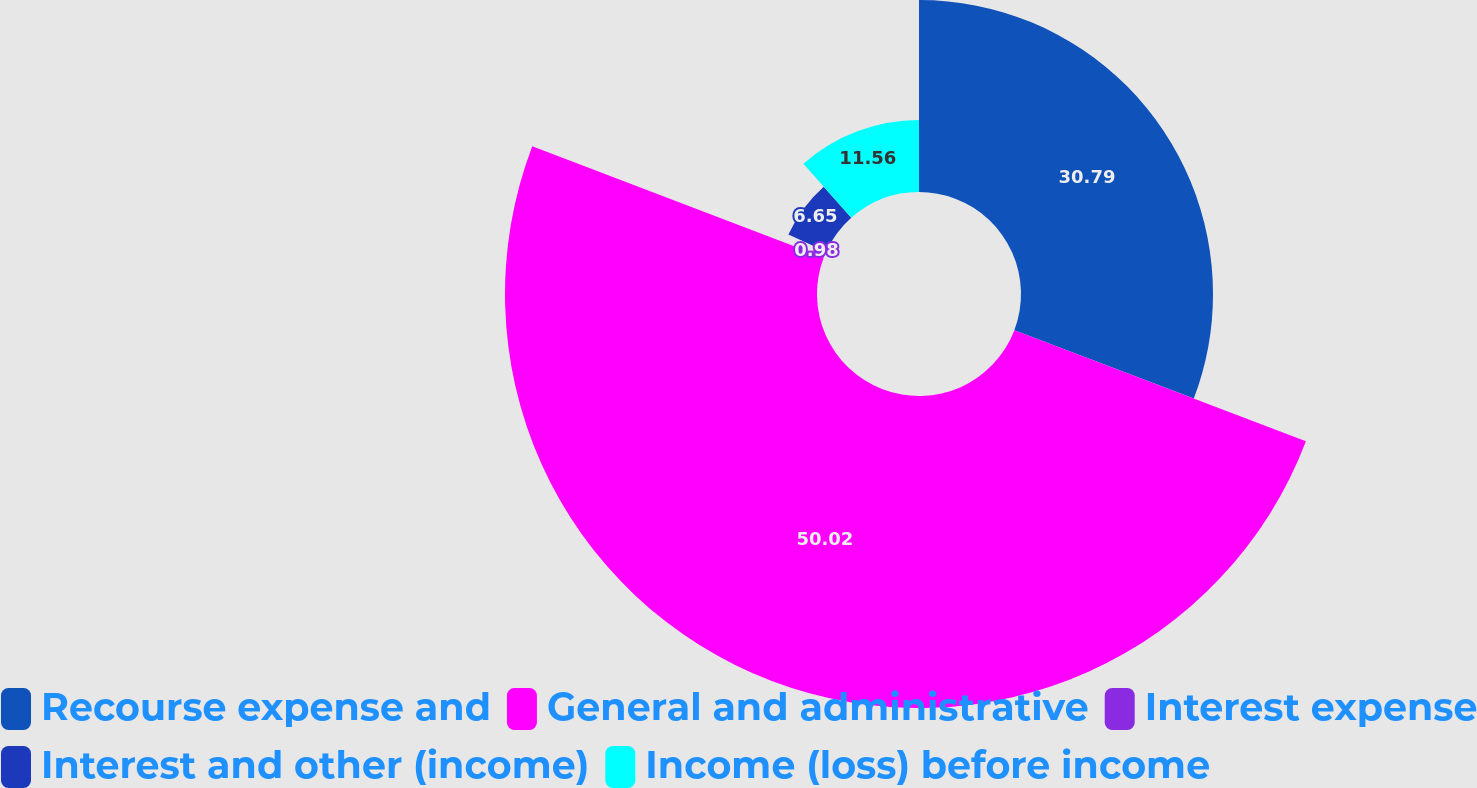Convert chart. <chart><loc_0><loc_0><loc_500><loc_500><pie_chart><fcel>Recourse expense and<fcel>General and administrative<fcel>Interest expense<fcel>Interest and other (income)<fcel>Income (loss) before income<nl><fcel>30.79%<fcel>50.03%<fcel>0.98%<fcel>6.65%<fcel>11.56%<nl></chart> 